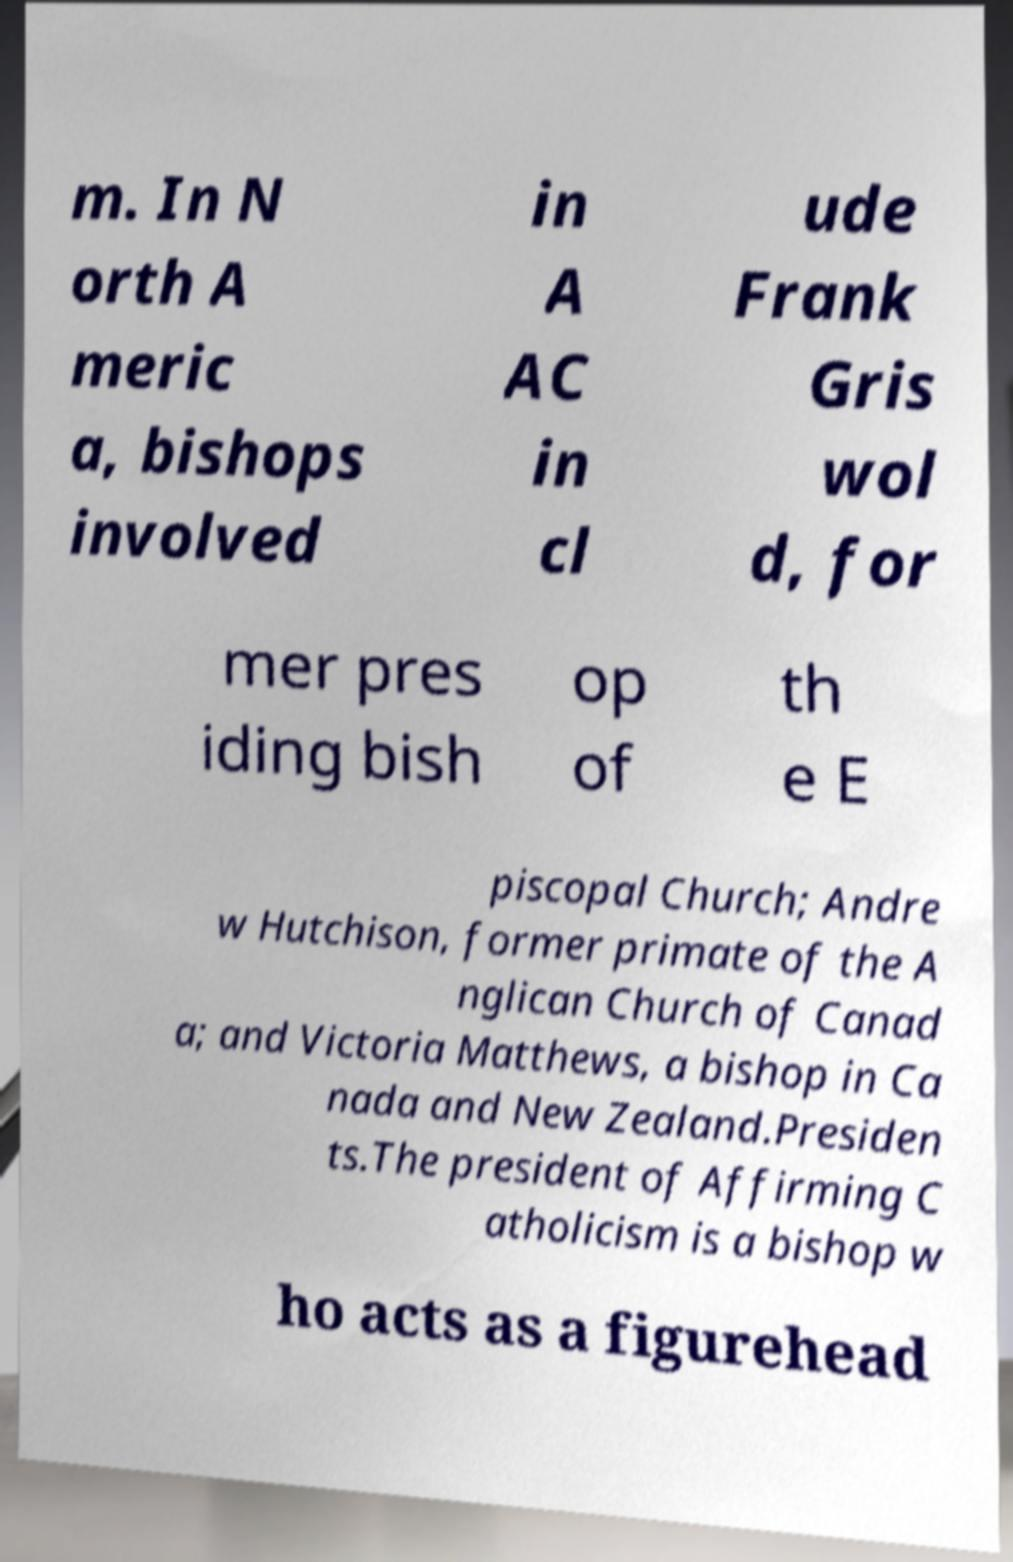I need the written content from this picture converted into text. Can you do that? m. In N orth A meric a, bishops involved in A AC in cl ude Frank Gris wol d, for mer pres iding bish op of th e E piscopal Church; Andre w Hutchison, former primate of the A nglican Church of Canad a; and Victoria Matthews, a bishop in Ca nada and New Zealand.Presiden ts.The president of Affirming C atholicism is a bishop w ho acts as a figurehead 